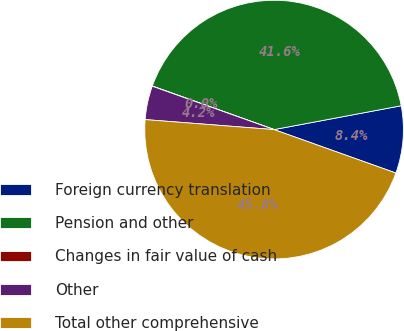Convert chart. <chart><loc_0><loc_0><loc_500><loc_500><pie_chart><fcel>Foreign currency translation<fcel>Pension and other<fcel>Changes in fair value of cash<fcel>Other<fcel>Total other comprehensive<nl><fcel>8.4%<fcel>41.59%<fcel>0.02%<fcel>4.21%<fcel>45.78%<nl></chart> 